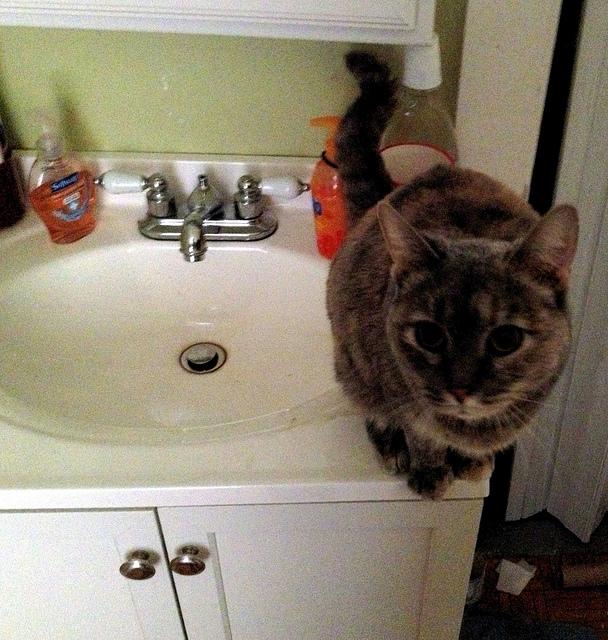Is the water on?
Be succinct. No. What else is on the sink?
Be succinct. Cat. What color is the liquid soap?
Give a very brief answer. Orange. What are the cats doing?
Short answer required. Sitting. Are the cats resting on a pet bed?
Short answer required. No. Where is the cat perched?
Write a very short answer. Sink. 